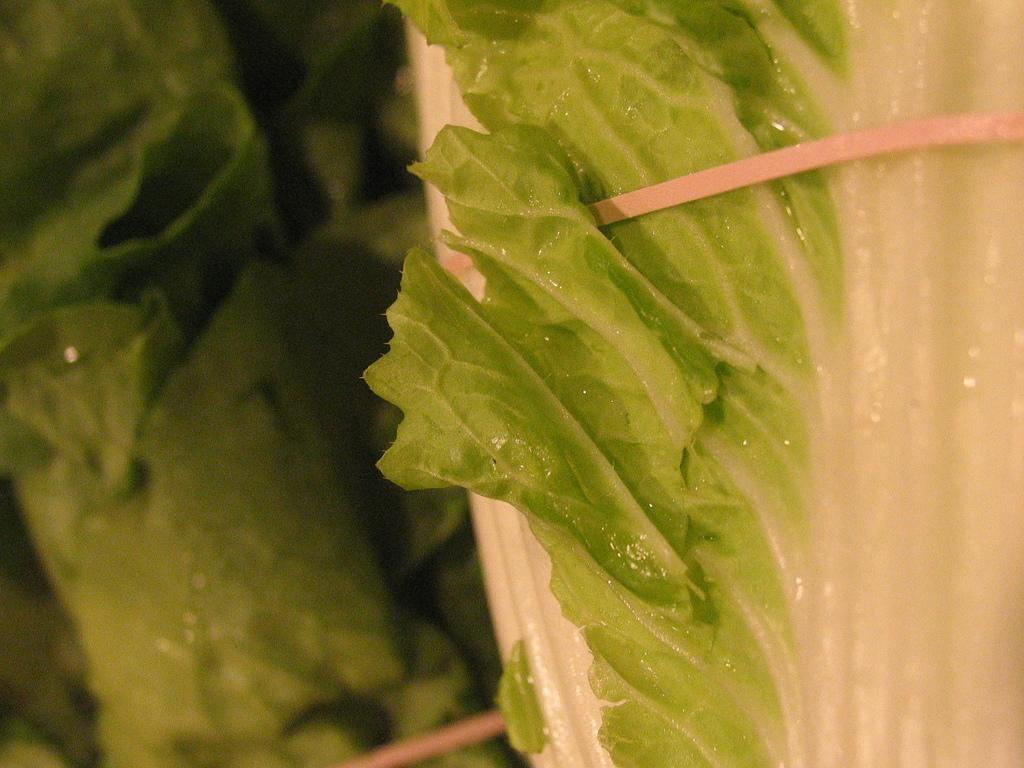What is present in the object in the image? There is a greenery leaf in an object in the image. What can be seen in the background of the image? The background of the image includes greenery in the left corner. What type of popcorn can be seen in the image? There is no popcorn present in the image. Is there a cobweb visible in the image? There is no mention of a cobweb in the provided facts, so it cannot be determined if one is present in the image. 